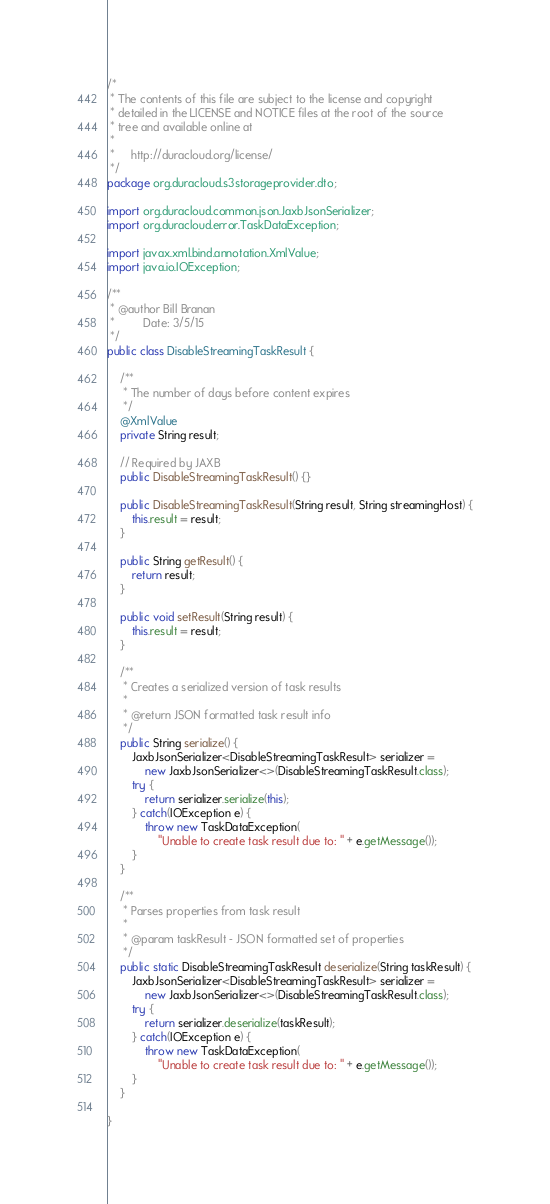<code> <loc_0><loc_0><loc_500><loc_500><_Java_>/*
 * The contents of this file are subject to the license and copyright
 * detailed in the LICENSE and NOTICE files at the root of the source
 * tree and available online at
 *
 *     http://duracloud.org/license/
 */
package org.duracloud.s3storageprovider.dto;

import org.duracloud.common.json.JaxbJsonSerializer;
import org.duracloud.error.TaskDataException;

import javax.xml.bind.annotation.XmlValue;
import java.io.IOException;

/**
 * @author Bill Branan
 *         Date: 3/5/15
 */
public class DisableStreamingTaskResult {

    /**
     * The number of days before content expires
     */
    @XmlValue
    private String result;

    // Required by JAXB
    public DisableStreamingTaskResult() {}

    public DisableStreamingTaskResult(String result, String streamingHost) {
        this.result = result;
    }

    public String getResult() {
        return result;
    }

    public void setResult(String result) {
        this.result = result;
    }

    /**
     * Creates a serialized version of task results
     *
     * @return JSON formatted task result info
     */
    public String serialize() {
        JaxbJsonSerializer<DisableStreamingTaskResult> serializer =
            new JaxbJsonSerializer<>(DisableStreamingTaskResult.class);
        try {
            return serializer.serialize(this);
        } catch(IOException e) {
            throw new TaskDataException(
                "Unable to create task result due to: " + e.getMessage());
        }
    }

    /**
     * Parses properties from task result
     *
     * @param taskResult - JSON formatted set of properties
     */
    public static DisableStreamingTaskResult deserialize(String taskResult) {
        JaxbJsonSerializer<DisableStreamingTaskResult> serializer =
            new JaxbJsonSerializer<>(DisableStreamingTaskResult.class);
        try {
            return serializer.deserialize(taskResult);
        } catch(IOException e) {
            throw new TaskDataException(
                "Unable to create task result due to: " + e.getMessage());
        }
    }
    
}
</code> 